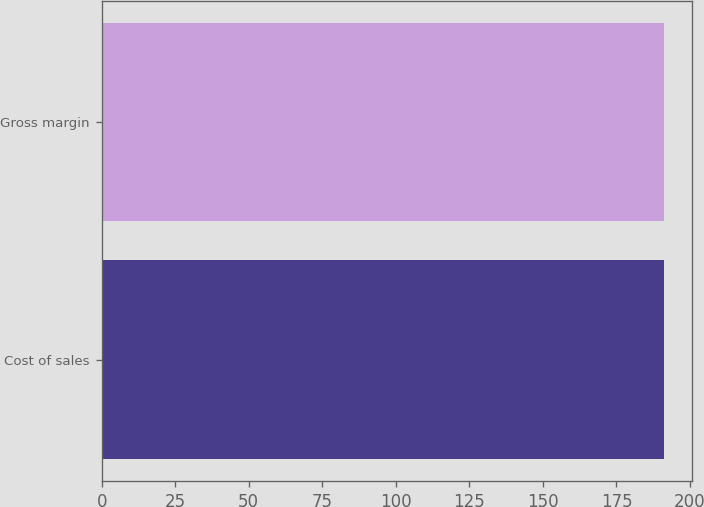Convert chart to OTSL. <chart><loc_0><loc_0><loc_500><loc_500><bar_chart><fcel>Cost of sales<fcel>Gross margin<nl><fcel>191<fcel>191.1<nl></chart> 